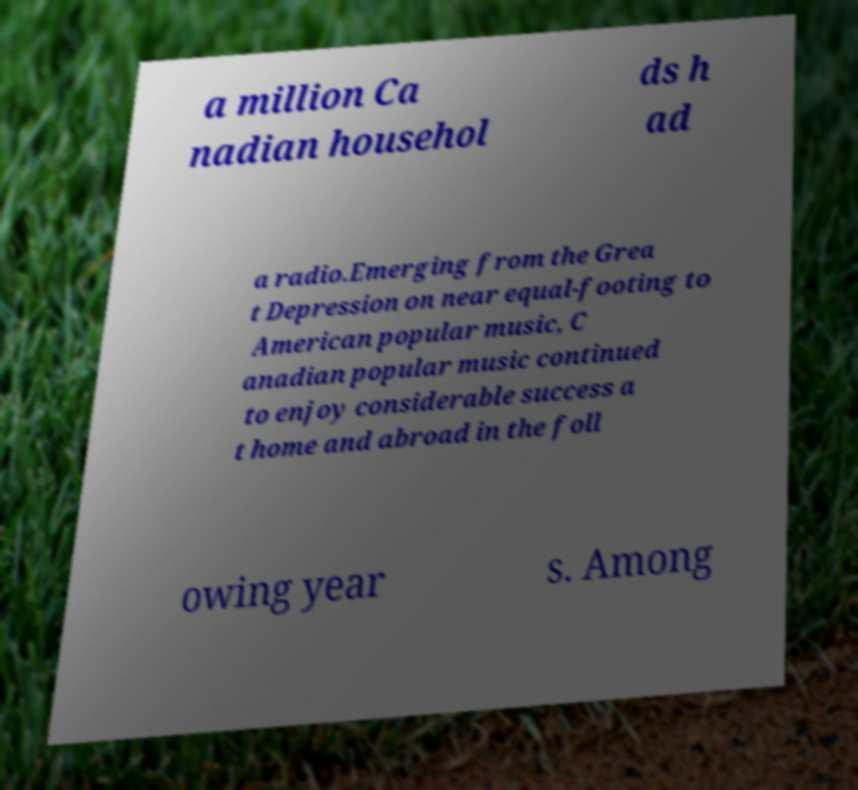For documentation purposes, I need the text within this image transcribed. Could you provide that? a million Ca nadian househol ds h ad a radio.Emerging from the Grea t Depression on near equal-footing to American popular music, C anadian popular music continued to enjoy considerable success a t home and abroad in the foll owing year s. Among 